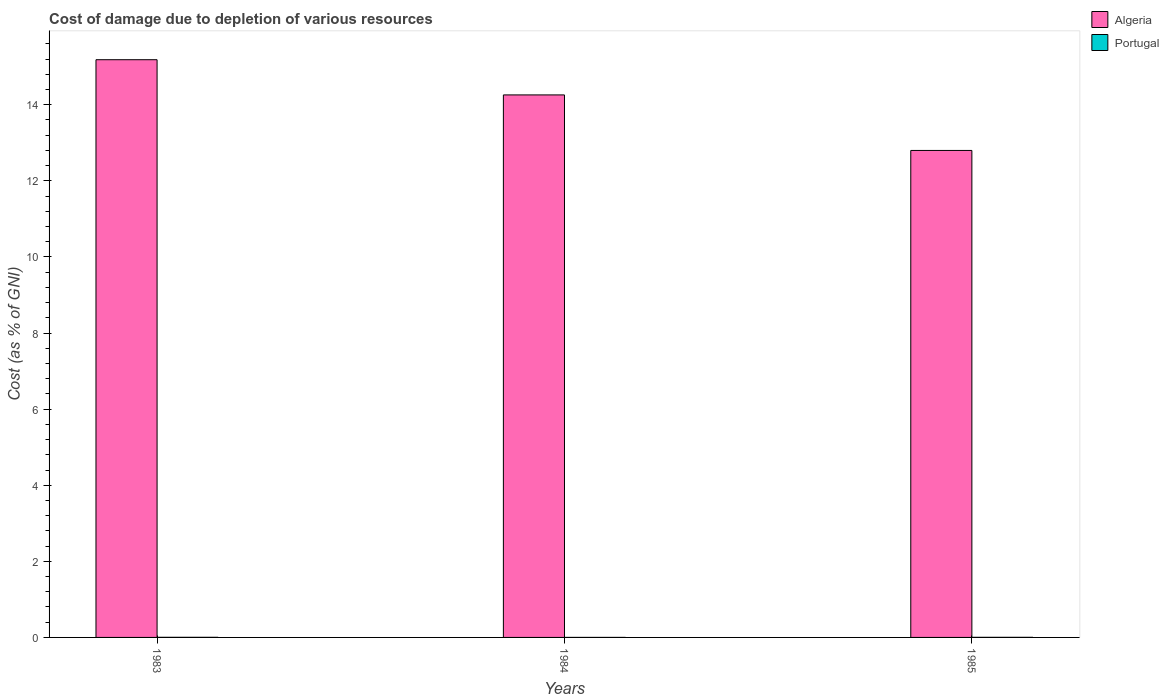How many groups of bars are there?
Ensure brevity in your answer.  3. Are the number of bars per tick equal to the number of legend labels?
Your answer should be compact. Yes. Are the number of bars on each tick of the X-axis equal?
Provide a short and direct response. Yes. How many bars are there on the 3rd tick from the left?
Provide a succinct answer. 2. What is the cost of damage caused due to the depletion of various resources in Portugal in 1985?
Keep it short and to the point. 0. Across all years, what is the maximum cost of damage caused due to the depletion of various resources in Algeria?
Your response must be concise. 15.18. Across all years, what is the minimum cost of damage caused due to the depletion of various resources in Algeria?
Make the answer very short. 12.8. In which year was the cost of damage caused due to the depletion of various resources in Portugal maximum?
Make the answer very short. 1983. In which year was the cost of damage caused due to the depletion of various resources in Portugal minimum?
Your answer should be very brief. 1984. What is the total cost of damage caused due to the depletion of various resources in Portugal in the graph?
Your answer should be compact. 0.01. What is the difference between the cost of damage caused due to the depletion of various resources in Algeria in 1983 and that in 1985?
Offer a very short reply. 2.38. What is the difference between the cost of damage caused due to the depletion of various resources in Portugal in 1983 and the cost of damage caused due to the depletion of various resources in Algeria in 1984?
Offer a very short reply. -14.25. What is the average cost of damage caused due to the depletion of various resources in Portugal per year?
Offer a terse response. 0. In the year 1983, what is the difference between the cost of damage caused due to the depletion of various resources in Algeria and cost of damage caused due to the depletion of various resources in Portugal?
Give a very brief answer. 15.18. In how many years, is the cost of damage caused due to the depletion of various resources in Portugal greater than 8.4 %?
Make the answer very short. 0. What is the ratio of the cost of damage caused due to the depletion of various resources in Algeria in 1983 to that in 1984?
Offer a very short reply. 1.06. What is the difference between the highest and the second highest cost of damage caused due to the depletion of various resources in Portugal?
Give a very brief answer. 0. What is the difference between the highest and the lowest cost of damage caused due to the depletion of various resources in Algeria?
Make the answer very short. 2.38. In how many years, is the cost of damage caused due to the depletion of various resources in Portugal greater than the average cost of damage caused due to the depletion of various resources in Portugal taken over all years?
Keep it short and to the point. 2. What does the 1st bar from the left in 1983 represents?
Offer a very short reply. Algeria. What does the 2nd bar from the right in 1983 represents?
Your answer should be very brief. Algeria. How many bars are there?
Ensure brevity in your answer.  6. How many years are there in the graph?
Offer a very short reply. 3. Are the values on the major ticks of Y-axis written in scientific E-notation?
Your answer should be compact. No. Does the graph contain grids?
Offer a very short reply. No. Where does the legend appear in the graph?
Your answer should be compact. Top right. What is the title of the graph?
Make the answer very short. Cost of damage due to depletion of various resources. Does "Heavily indebted poor countries" appear as one of the legend labels in the graph?
Make the answer very short. No. What is the label or title of the X-axis?
Give a very brief answer. Years. What is the label or title of the Y-axis?
Provide a short and direct response. Cost (as % of GNI). What is the Cost (as % of GNI) of Algeria in 1983?
Keep it short and to the point. 15.18. What is the Cost (as % of GNI) in Portugal in 1983?
Provide a succinct answer. 0. What is the Cost (as % of GNI) in Algeria in 1984?
Provide a short and direct response. 14.26. What is the Cost (as % of GNI) in Portugal in 1984?
Ensure brevity in your answer.  0. What is the Cost (as % of GNI) of Algeria in 1985?
Make the answer very short. 12.8. What is the Cost (as % of GNI) in Portugal in 1985?
Provide a short and direct response. 0. Across all years, what is the maximum Cost (as % of GNI) in Algeria?
Give a very brief answer. 15.18. Across all years, what is the maximum Cost (as % of GNI) of Portugal?
Make the answer very short. 0. Across all years, what is the minimum Cost (as % of GNI) in Algeria?
Provide a short and direct response. 12.8. Across all years, what is the minimum Cost (as % of GNI) in Portugal?
Offer a very short reply. 0. What is the total Cost (as % of GNI) in Algeria in the graph?
Your response must be concise. 42.24. What is the total Cost (as % of GNI) in Portugal in the graph?
Your answer should be very brief. 0.01. What is the difference between the Cost (as % of GNI) of Algeria in 1983 and that in 1984?
Offer a terse response. 0.93. What is the difference between the Cost (as % of GNI) of Portugal in 1983 and that in 1984?
Your answer should be compact. 0. What is the difference between the Cost (as % of GNI) in Algeria in 1983 and that in 1985?
Give a very brief answer. 2.38. What is the difference between the Cost (as % of GNI) of Portugal in 1983 and that in 1985?
Make the answer very short. 0. What is the difference between the Cost (as % of GNI) in Algeria in 1984 and that in 1985?
Provide a short and direct response. 1.46. What is the difference between the Cost (as % of GNI) of Portugal in 1984 and that in 1985?
Offer a terse response. -0. What is the difference between the Cost (as % of GNI) of Algeria in 1983 and the Cost (as % of GNI) of Portugal in 1984?
Ensure brevity in your answer.  15.18. What is the difference between the Cost (as % of GNI) of Algeria in 1983 and the Cost (as % of GNI) of Portugal in 1985?
Give a very brief answer. 15.18. What is the difference between the Cost (as % of GNI) of Algeria in 1984 and the Cost (as % of GNI) of Portugal in 1985?
Your response must be concise. 14.26. What is the average Cost (as % of GNI) in Algeria per year?
Provide a succinct answer. 14.08. What is the average Cost (as % of GNI) of Portugal per year?
Your answer should be very brief. 0. In the year 1983, what is the difference between the Cost (as % of GNI) in Algeria and Cost (as % of GNI) in Portugal?
Provide a short and direct response. 15.18. In the year 1984, what is the difference between the Cost (as % of GNI) of Algeria and Cost (as % of GNI) of Portugal?
Your answer should be very brief. 14.26. In the year 1985, what is the difference between the Cost (as % of GNI) of Algeria and Cost (as % of GNI) of Portugal?
Give a very brief answer. 12.8. What is the ratio of the Cost (as % of GNI) of Algeria in 1983 to that in 1984?
Keep it short and to the point. 1.06. What is the ratio of the Cost (as % of GNI) of Portugal in 1983 to that in 1984?
Offer a very short reply. 9.64. What is the ratio of the Cost (as % of GNI) of Algeria in 1983 to that in 1985?
Provide a short and direct response. 1.19. What is the ratio of the Cost (as % of GNI) in Portugal in 1983 to that in 1985?
Your response must be concise. 1.22. What is the ratio of the Cost (as % of GNI) in Algeria in 1984 to that in 1985?
Your response must be concise. 1.11. What is the ratio of the Cost (as % of GNI) of Portugal in 1984 to that in 1985?
Ensure brevity in your answer.  0.13. What is the difference between the highest and the second highest Cost (as % of GNI) in Algeria?
Your answer should be very brief. 0.93. What is the difference between the highest and the lowest Cost (as % of GNI) in Algeria?
Offer a terse response. 2.38. What is the difference between the highest and the lowest Cost (as % of GNI) in Portugal?
Ensure brevity in your answer.  0. 